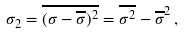<formula> <loc_0><loc_0><loc_500><loc_500>\sigma _ { 2 } = \overline { ( \sigma - \overline { \sigma } ) ^ { 2 } } = \overline { \sigma ^ { 2 } } - \overline { \sigma } ^ { 2 } \, ,</formula> 